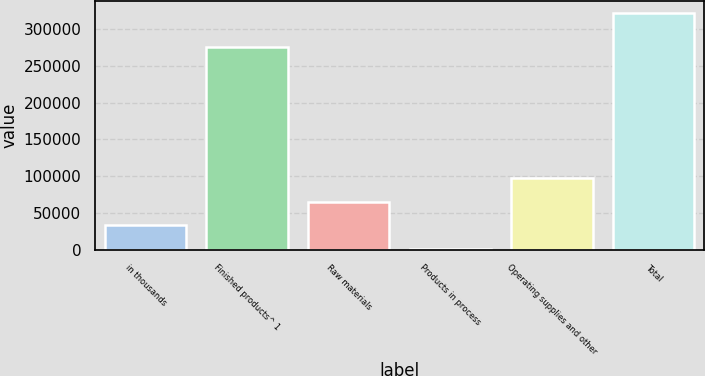Convert chart to OTSL. <chart><loc_0><loc_0><loc_500><loc_500><bar_chart><fcel>in thousands<fcel>Finished products^ 1<fcel>Raw materials<fcel>Products in process<fcel>Operating supplies and other<fcel>Total<nl><fcel>33305.4<fcel>275172<fcel>65360.8<fcel>1250<fcel>97416.2<fcel>321804<nl></chart> 